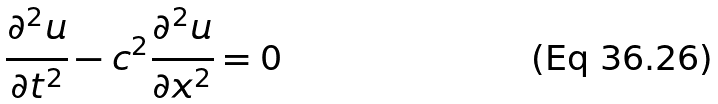<formula> <loc_0><loc_0><loc_500><loc_500>\frac { \partial ^ { 2 } u } { \partial t ^ { 2 } } - c ^ { 2 } \frac { \partial ^ { 2 } u } { \partial x ^ { 2 } } = 0</formula> 